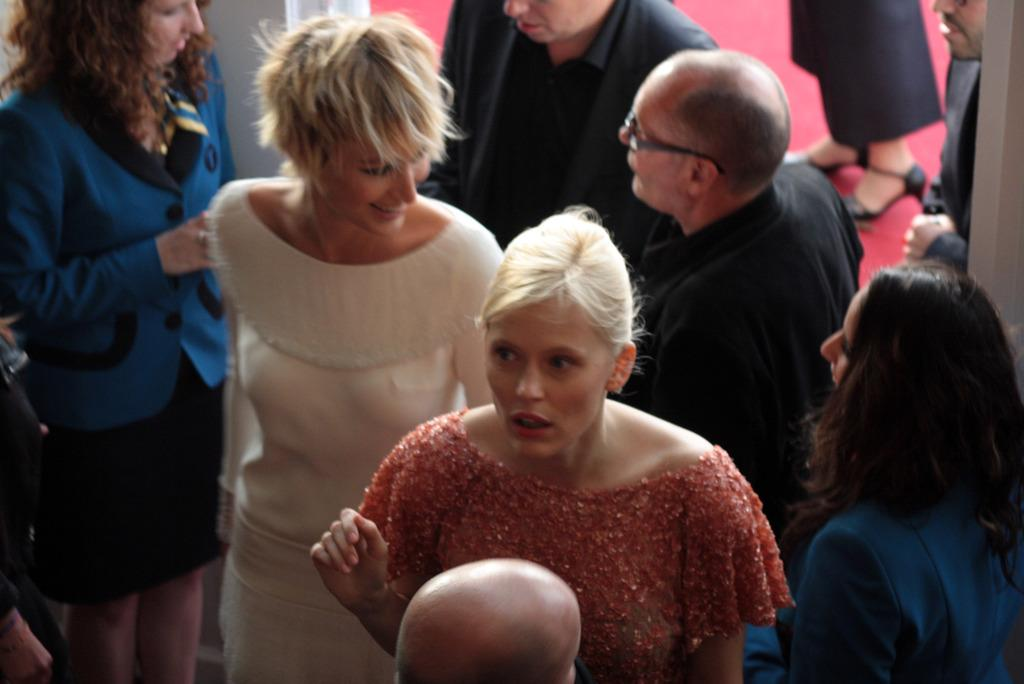Who is present in the image? There is a woman in the image. What is the woman doing in the image? The woman is smiling in the image. Are there any other people in the image besides the woman? Yes, there are people around the woman in the image. What type of flag is being waved by the woman in the image? There is no flag present in the image, and the woman is not waving anything. 